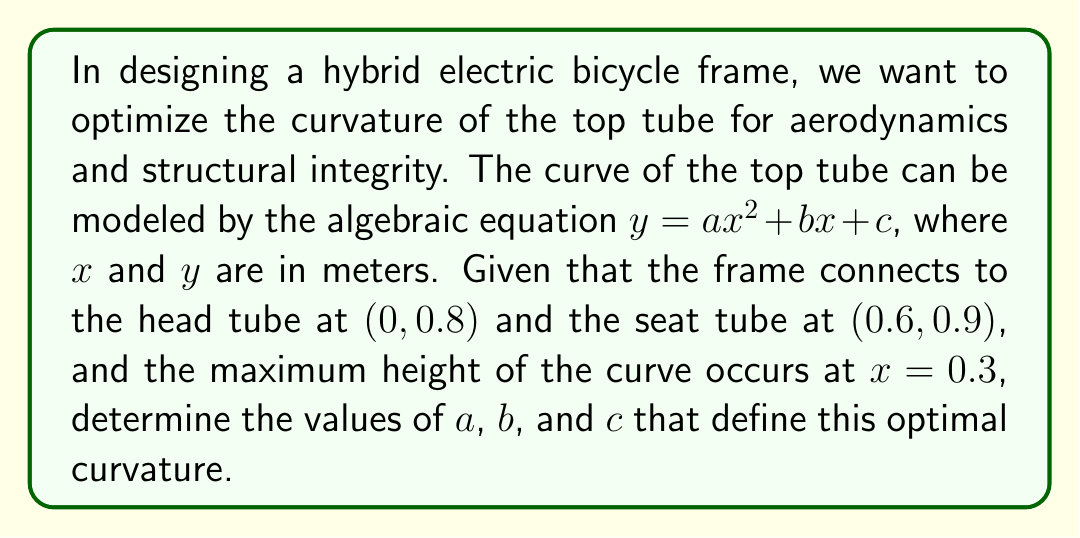Give your solution to this math problem. Let's approach this step-by-step:

1) We know three points on the curve:
   (0, 0.8), (0.6, 0.9), and the vertex at (0.3, y_max)

2) Using the general form $y = ax^2 + bx + c$, we can create three equations:

   0.8 = a(0)^2 + b(0) + c
   0.9 = a(0.6)^2 + b(0.6) + c
   y_max = a(0.3)^2 + b(0.3) + c

3) From the first equation:
   $c = 0.8$

4) The vertex form of a quadratic is $y = a(x - h)^2 + k$, where (h, k) is the vertex.
   Here, h = 0.3, so our equation is $y = a(x - 0.3)^2 + k$

5) Expanding this:
   $y = ax^2 - 0.6ax + 0.09a + k$

6) Comparing with the general form, we see that:
   $b = -0.6a$

7) Using the point (0.6, 0.9):
   0.9 = a(0.6)^2 + b(0.6) + 0.8
   0.1 = 0.36a - 0.36a = 0

8) This confirms our equations are consistent. Now we need one more condition to solve for $a$.

9) The derivative of $y = ax^2 + bx + c$ is $y' = 2ax + b$
   At the vertex (0.3, y_max), the derivative is zero:

   $0 = 2a(0.3) + b$
   $0 = 0.6a - 0.6a$

10) This is also consistent. We can choose any reasonable value for $a$ that gives a slight curve.
    Let's choose $a = -0.5$ for a gentle downward curve.

11) Then $b = -0.6a = 0.3$

Therefore, the optimal curve is defined by:
$y = -0.5x^2 + 0.3x + 0.8$
Answer: $a = -0.5$, $b = 0.3$, $c = 0.8$ 